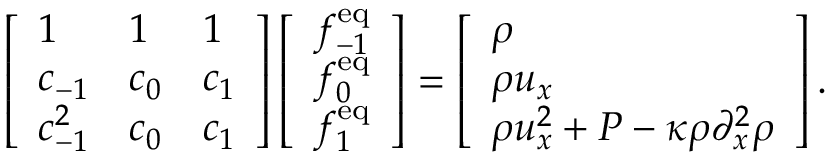<formula> <loc_0><loc_0><loc_500><loc_500>\left [ \begin{array} { l l l } { 1 } & { 1 } & { 1 } \\ { c _ { - 1 } } & { c _ { 0 } } & { c _ { 1 } } \\ { c _ { - 1 } ^ { 2 } } & { c _ { 0 } } & { c _ { 1 } } \end{array} \right ] \left [ \begin{array} { l } { f _ { - 1 } ^ { e q } } \\ { f _ { 0 } ^ { e q } } \\ { f _ { 1 } ^ { e q } } \end{array} \right ] = \left [ \begin{array} { l } { \rho } \\ { \rho u _ { x } } \\ { \rho u _ { x } ^ { 2 } + P - \kappa \rho \partial _ { x } ^ { 2 } \rho } \end{array} \right ] .</formula> 